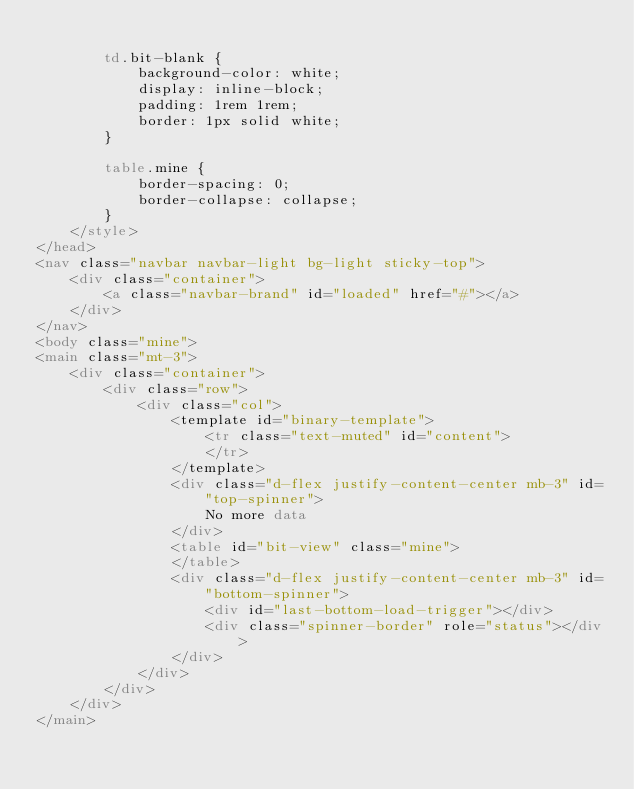<code> <loc_0><loc_0><loc_500><loc_500><_HTML_>
        td.bit-blank {
            background-color: white;
            display: inline-block;
            padding: 1rem 1rem;
            border: 1px solid white;
        }

        table.mine {
            border-spacing: 0;
            border-collapse: collapse;
        }
    </style>
</head>
<nav class="navbar navbar-light bg-light sticky-top">
    <div class="container">
        <a class="navbar-brand" id="loaded" href="#"></a>
    </div>
</nav>
<body class="mine">
<main class="mt-3">
    <div class="container">
        <div class="row">
            <div class="col">
                <template id="binary-template">
                    <tr class="text-muted" id="content">
                    </tr>
                </template>
                <div class="d-flex justify-content-center mb-3" id="top-spinner">
                    No more data
                </div>
                <table id="bit-view" class="mine">
                </table>
                <div class="d-flex justify-content-center mb-3" id="bottom-spinner">
                    <div id="last-bottom-load-trigger"></div>
                    <div class="spinner-border" role="status"></div>
                </div>
            </div>
        </div>
    </div>
</main></code> 